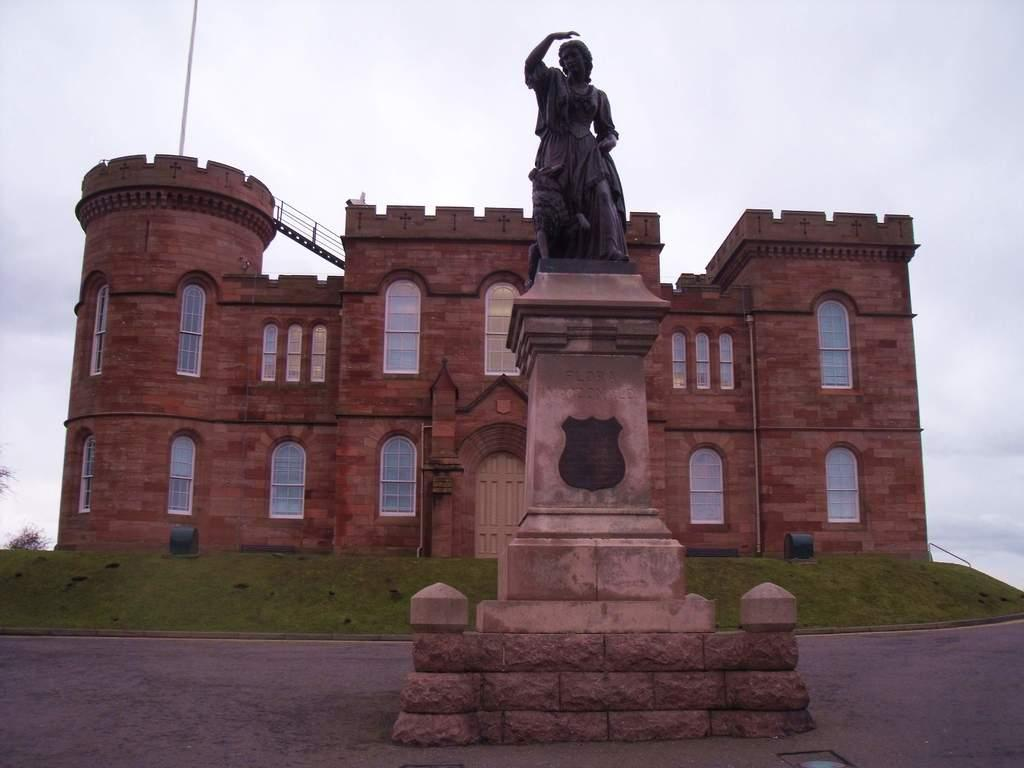What type of structure is present in the image? There is a building in the image. What feature can be seen on the building? The building has windows. What type of vegetation is visible in the image? There is green grass in the image. What other object can be seen in the image besides the building and grass? There is a statue in the image. What is the color of the statue? The statue is black in color. What is the color of the sky in the image? The sky is blue and white in color. How many chickens are sitting on the statue's nose in the image? There are no chickens or noses present in the image, and therefore no such interaction can be observed. 